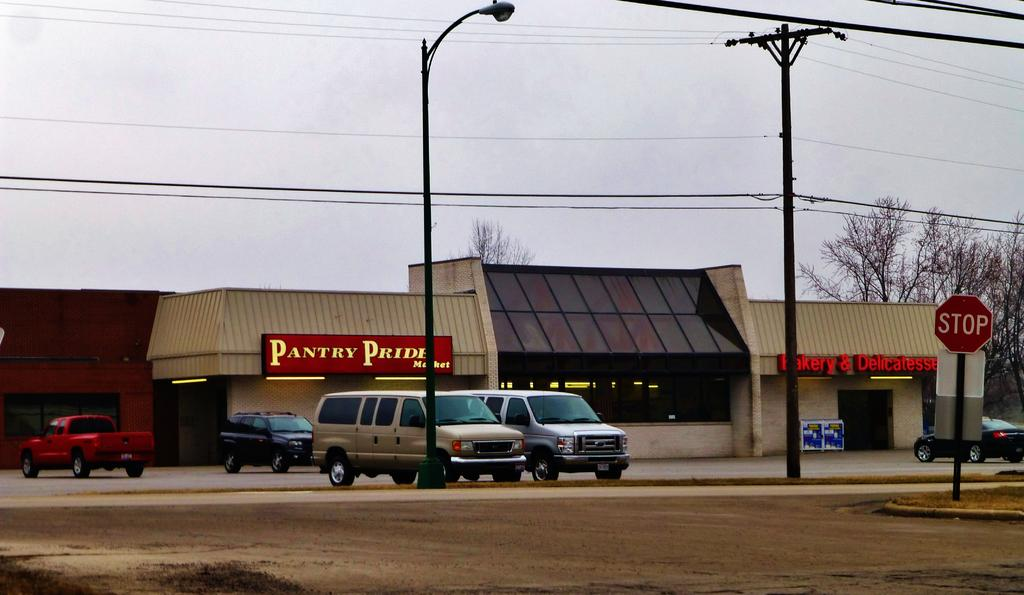What type of vehicles can be seen on the road in the image? There are cars on the road in the image. What structures are visible in the background of the image? There is a building with trees behind it in the image. What type of infrastructure is present in the image? There are electric poles in the image. What part of the natural environment is visible in the image? The sky is visible in the image. Where is the cord for the sweater located in the image? There is no sweater or cord present in the image. What type of food is being served in the lunchroom in the image? There is no lunchroom present in the image. 